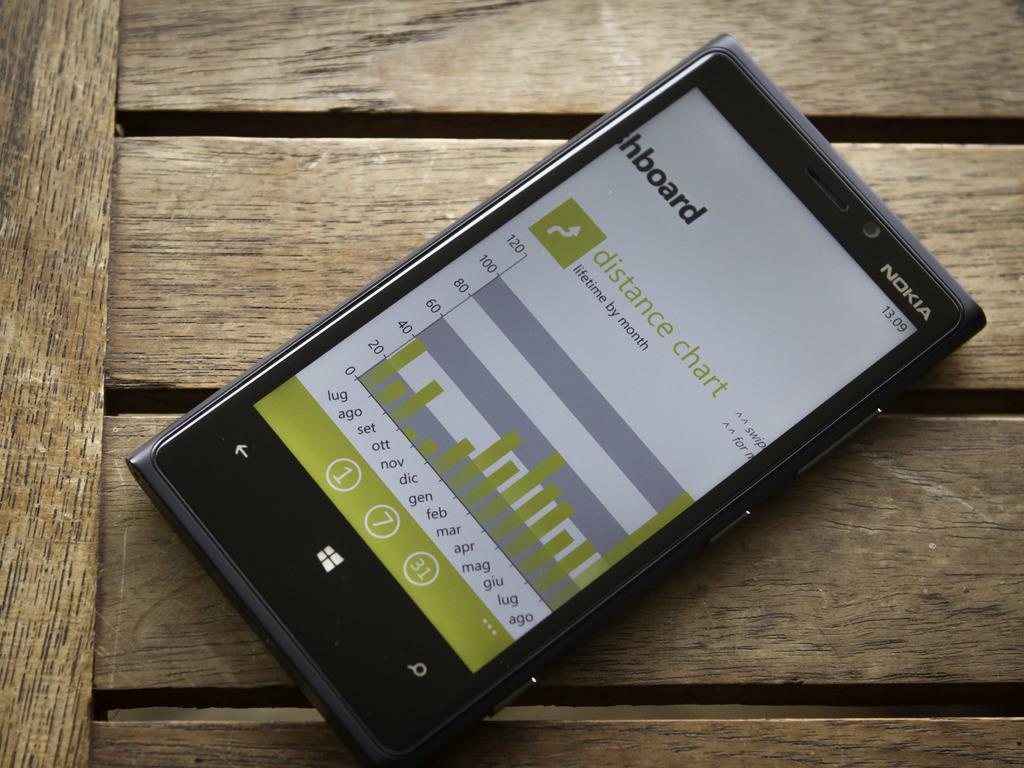<image>
Give a short and clear explanation of the subsequent image. A Nokia brand black windows cellphone with a graph shown on the screen 